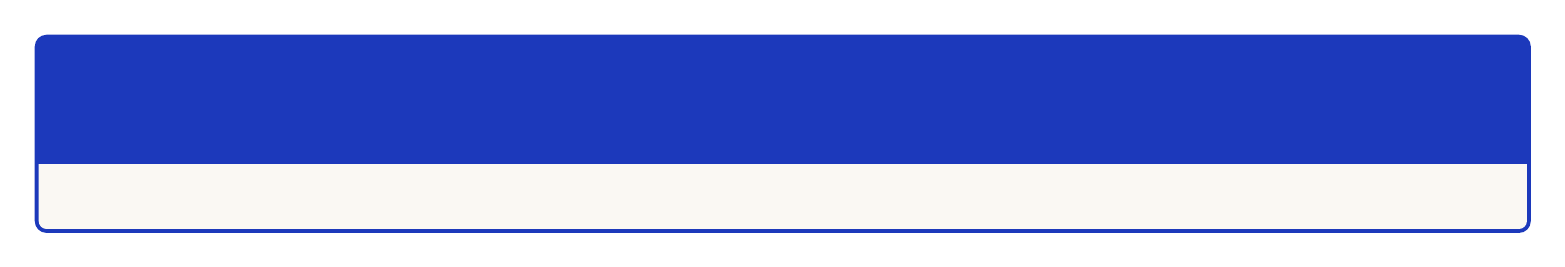what is the date of the Tehran International Conference on Persian Linguistics? The date is specified in the event details for the Tehran International Conference on Persian Linguistics.
Answer: September 15-17, 2023 who is the keynote speaker for the International Conference on Persian Translation Technologies? The keynote speaker is mentioned in the details of the conference.
Answer: Dr. Mohsen Ahmadi Mirak where is the Workshop on Persian-English Literary Translation being held? The location is provided in the event details for the workshop.
Answer: Ferdowsi University of Mashhad, Iran how many days does the Middle Eastern Languages and Linguistics Symposium last? The duration is indicated in the event's date range, which covers a span of days.
Answer: 3 days which university is hosting the Workshop on Persian Corpus Linguistics? The hosting institution is included in the workshop's details.
Answer: University of Isfahan what topic will be covered in the "Featured" section of the Middle Eastern Languages and Linguistics Symposium? The featured topic is listed in the event description.
Answer: Comparative Analysis of Persian and Arabic Dialects who is the instructor for the Workshop on Persian Corpus Linguistics? The instructor's name is given in the workshop's details.
Answer: Dr. Gholamhossein Karimi-Doostan what is the email contact for the conferences? The email contact information is provided at the end of the document.
Answer: info@persianlingconferences.org 